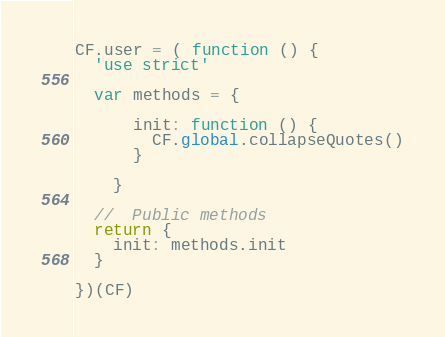Convert code to text. <code><loc_0><loc_0><loc_500><loc_500><_JavaScript_>CF.user = ( function () {
  'use strict'

  var methods = {

      init: function () {
        CF.global.collapseQuotes()
      }

    }

  //  Public methods
  return {
    init: methods.init
  }

})(CF)
</code> 